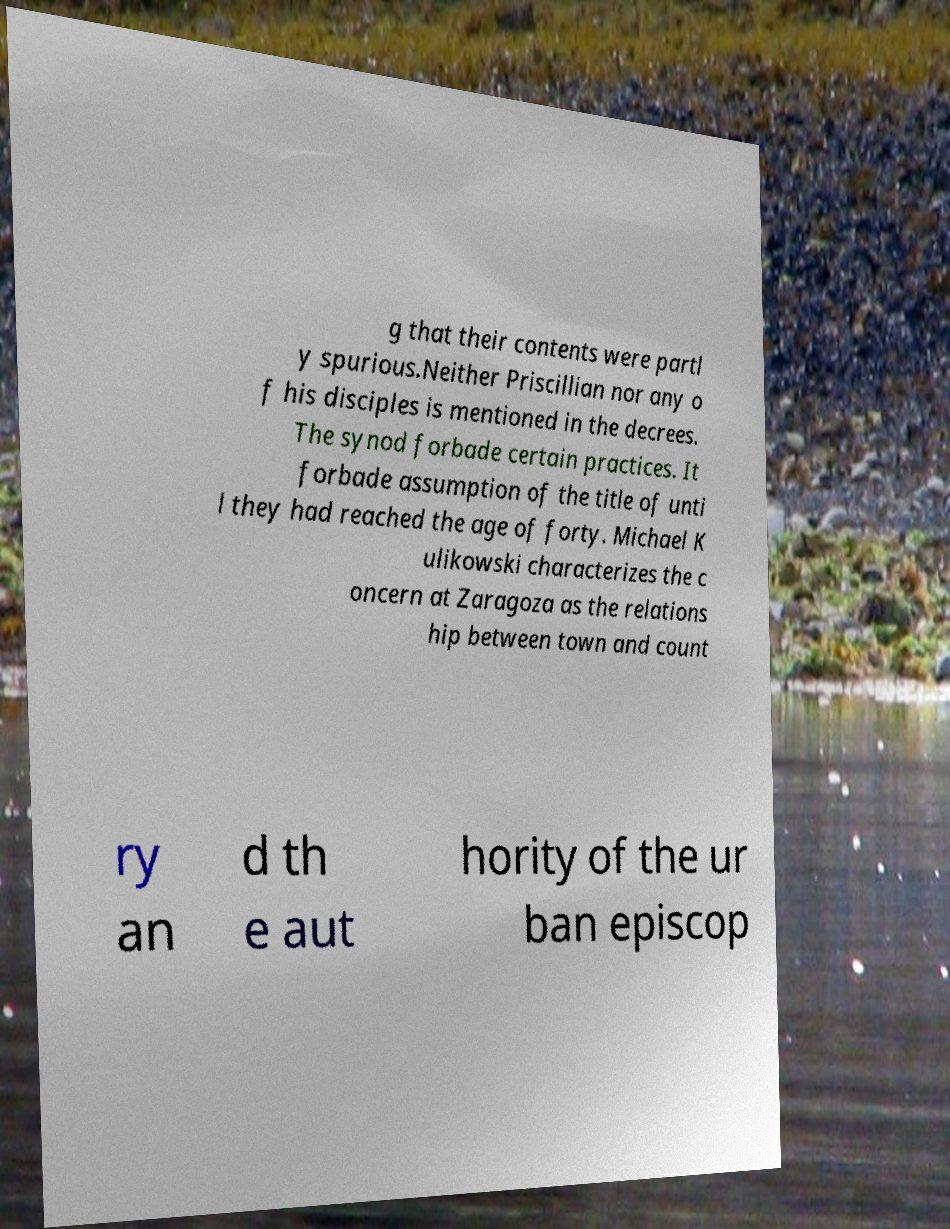Could you assist in decoding the text presented in this image and type it out clearly? g that their contents were partl y spurious.Neither Priscillian nor any o f his disciples is mentioned in the decrees. The synod forbade certain practices. It forbade assumption of the title of unti l they had reached the age of forty. Michael K ulikowski characterizes the c oncern at Zaragoza as the relations hip between town and count ry an d th e aut hority of the ur ban episcop 